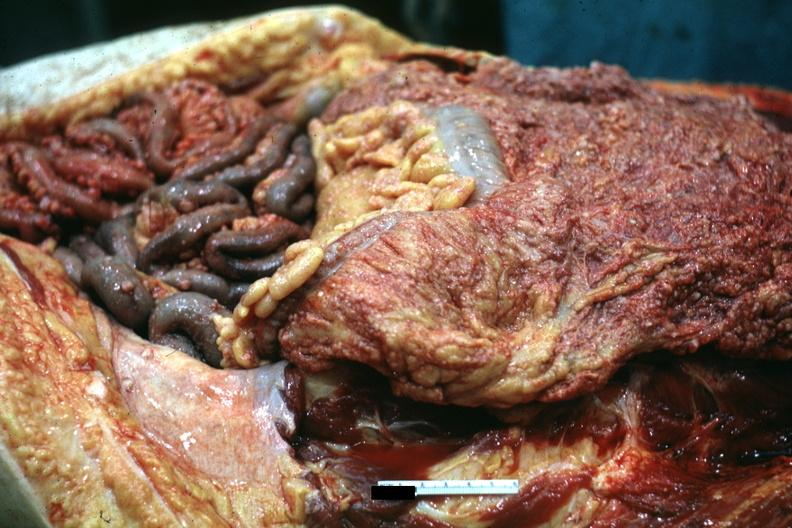s peritoneum present?
Answer the question using a single word or phrase. Yes 